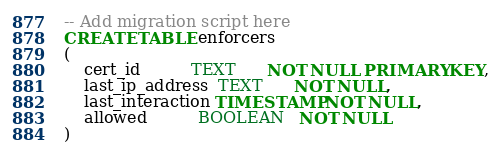<code> <loc_0><loc_0><loc_500><loc_500><_SQL_>-- Add migration script here
CREATE TABLE enforcers
(
    cert_id          TEXT      NOT NULL PRIMARY KEY,
    last_ip_address  TEXT      NOT NULL,
    last_interaction TIMESTAMP NOT NULL,
    allowed          BOOLEAN   NOT NULL
)</code> 